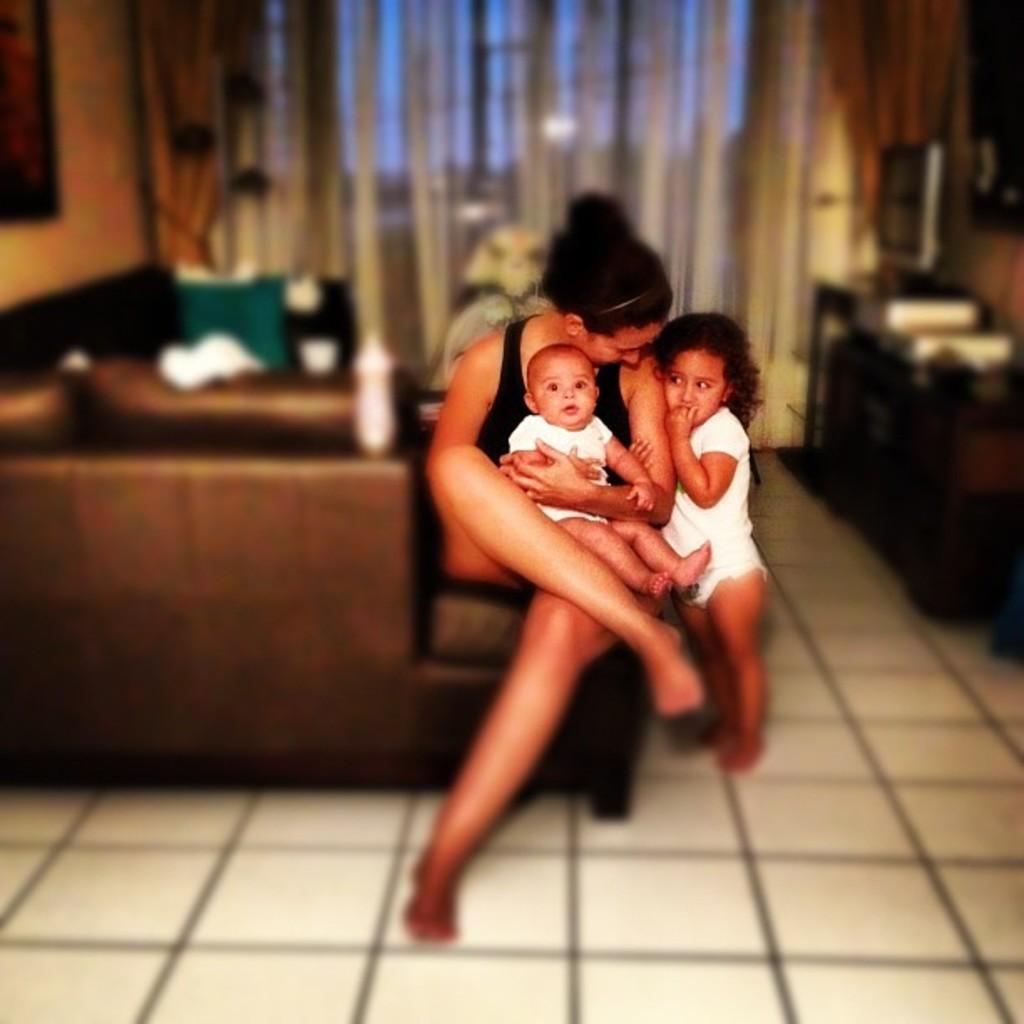Describe this image in one or two sentences. In this image we can see a woman wearing black color dress sitting on a couch holding kid in her hands by placing on lap, there is another kid wearing white color dress also standing near to her and in the background of the image there is couch, curtain and some table. 